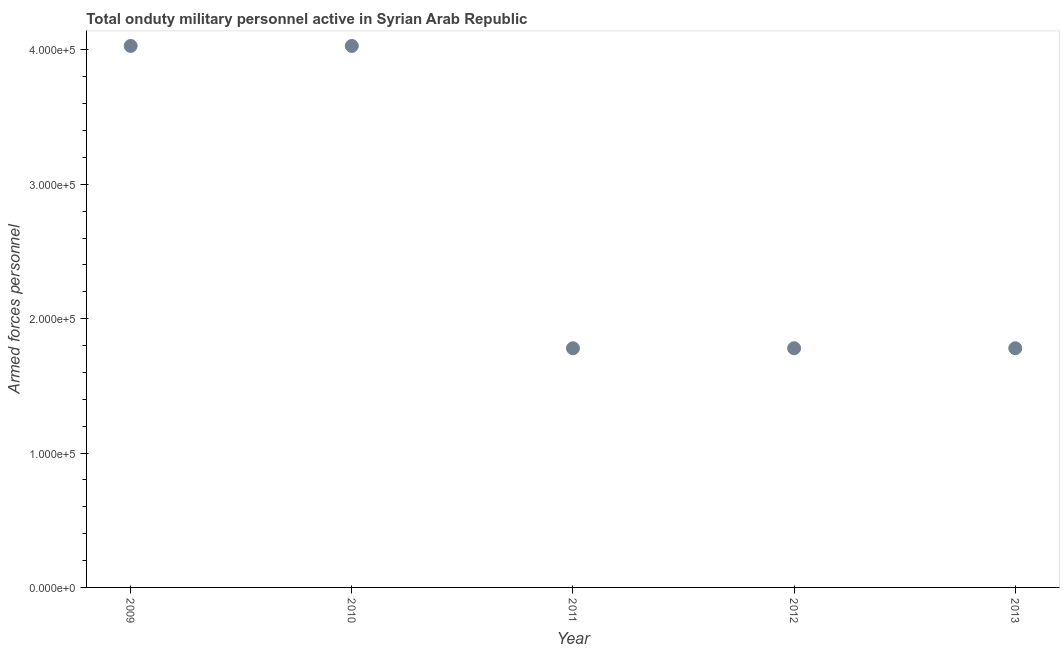What is the number of armed forces personnel in 2013?
Make the answer very short. 1.78e+05. Across all years, what is the maximum number of armed forces personnel?
Provide a succinct answer. 4.03e+05. Across all years, what is the minimum number of armed forces personnel?
Ensure brevity in your answer.  1.78e+05. In which year was the number of armed forces personnel minimum?
Your answer should be very brief. 2011. What is the sum of the number of armed forces personnel?
Provide a succinct answer. 1.34e+06. What is the difference between the number of armed forces personnel in 2010 and 2013?
Your answer should be compact. 2.25e+05. What is the average number of armed forces personnel per year?
Your response must be concise. 2.68e+05. What is the median number of armed forces personnel?
Provide a succinct answer. 1.78e+05. Do a majority of the years between 2011 and 2012 (inclusive) have number of armed forces personnel greater than 300000 ?
Ensure brevity in your answer.  No. What is the ratio of the number of armed forces personnel in 2009 to that in 2011?
Provide a succinct answer. 2.26. Is the number of armed forces personnel in 2009 less than that in 2013?
Ensure brevity in your answer.  No. Is the sum of the number of armed forces personnel in 2010 and 2013 greater than the maximum number of armed forces personnel across all years?
Your answer should be compact. Yes. What is the difference between the highest and the lowest number of armed forces personnel?
Provide a short and direct response. 2.25e+05. How many dotlines are there?
Make the answer very short. 1. What is the difference between two consecutive major ticks on the Y-axis?
Make the answer very short. 1.00e+05. Does the graph contain grids?
Provide a short and direct response. No. What is the title of the graph?
Your answer should be very brief. Total onduty military personnel active in Syrian Arab Republic. What is the label or title of the X-axis?
Your answer should be compact. Year. What is the label or title of the Y-axis?
Ensure brevity in your answer.  Armed forces personnel. What is the Armed forces personnel in 2009?
Offer a terse response. 4.03e+05. What is the Armed forces personnel in 2010?
Make the answer very short. 4.03e+05. What is the Armed forces personnel in 2011?
Your response must be concise. 1.78e+05. What is the Armed forces personnel in 2012?
Ensure brevity in your answer.  1.78e+05. What is the Armed forces personnel in 2013?
Offer a very short reply. 1.78e+05. What is the difference between the Armed forces personnel in 2009 and 2010?
Ensure brevity in your answer.  0. What is the difference between the Armed forces personnel in 2009 and 2011?
Keep it short and to the point. 2.25e+05. What is the difference between the Armed forces personnel in 2009 and 2012?
Make the answer very short. 2.25e+05. What is the difference between the Armed forces personnel in 2009 and 2013?
Your response must be concise. 2.25e+05. What is the difference between the Armed forces personnel in 2010 and 2011?
Your answer should be very brief. 2.25e+05. What is the difference between the Armed forces personnel in 2010 and 2012?
Ensure brevity in your answer.  2.25e+05. What is the difference between the Armed forces personnel in 2010 and 2013?
Provide a short and direct response. 2.25e+05. What is the difference between the Armed forces personnel in 2011 and 2013?
Ensure brevity in your answer.  0. What is the ratio of the Armed forces personnel in 2009 to that in 2010?
Ensure brevity in your answer.  1. What is the ratio of the Armed forces personnel in 2009 to that in 2011?
Provide a short and direct response. 2.26. What is the ratio of the Armed forces personnel in 2009 to that in 2012?
Your response must be concise. 2.26. What is the ratio of the Armed forces personnel in 2009 to that in 2013?
Your response must be concise. 2.26. What is the ratio of the Armed forces personnel in 2010 to that in 2011?
Your response must be concise. 2.26. What is the ratio of the Armed forces personnel in 2010 to that in 2012?
Your answer should be compact. 2.26. What is the ratio of the Armed forces personnel in 2010 to that in 2013?
Make the answer very short. 2.26. What is the ratio of the Armed forces personnel in 2011 to that in 2012?
Provide a succinct answer. 1. 